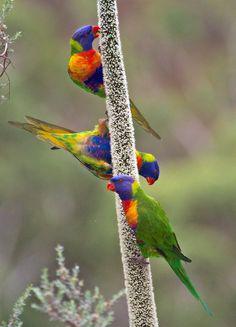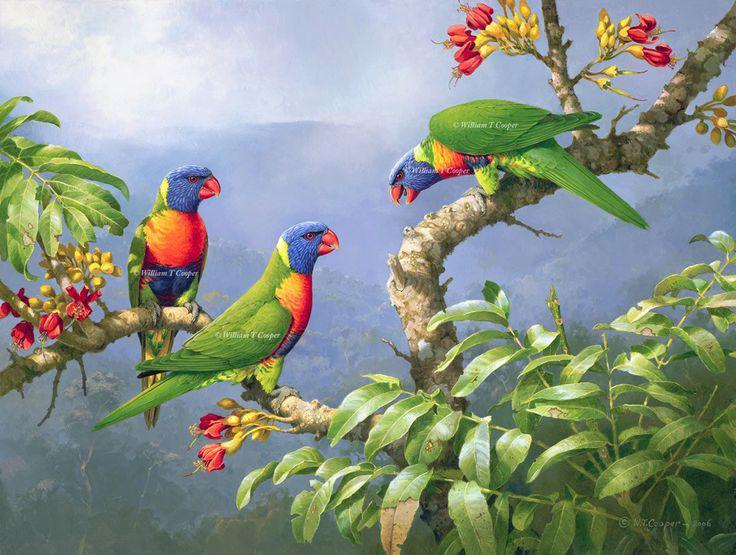The first image is the image on the left, the second image is the image on the right. Assess this claim about the two images: "At least one of the images shows three colourful parrots perched on a branch.". Correct or not? Answer yes or no. Yes. The first image is the image on the left, the second image is the image on the right. Analyze the images presented: Is the assertion "At least two parrots are perched in branches containing bright red flower-like growths." valid? Answer yes or no. Yes. 